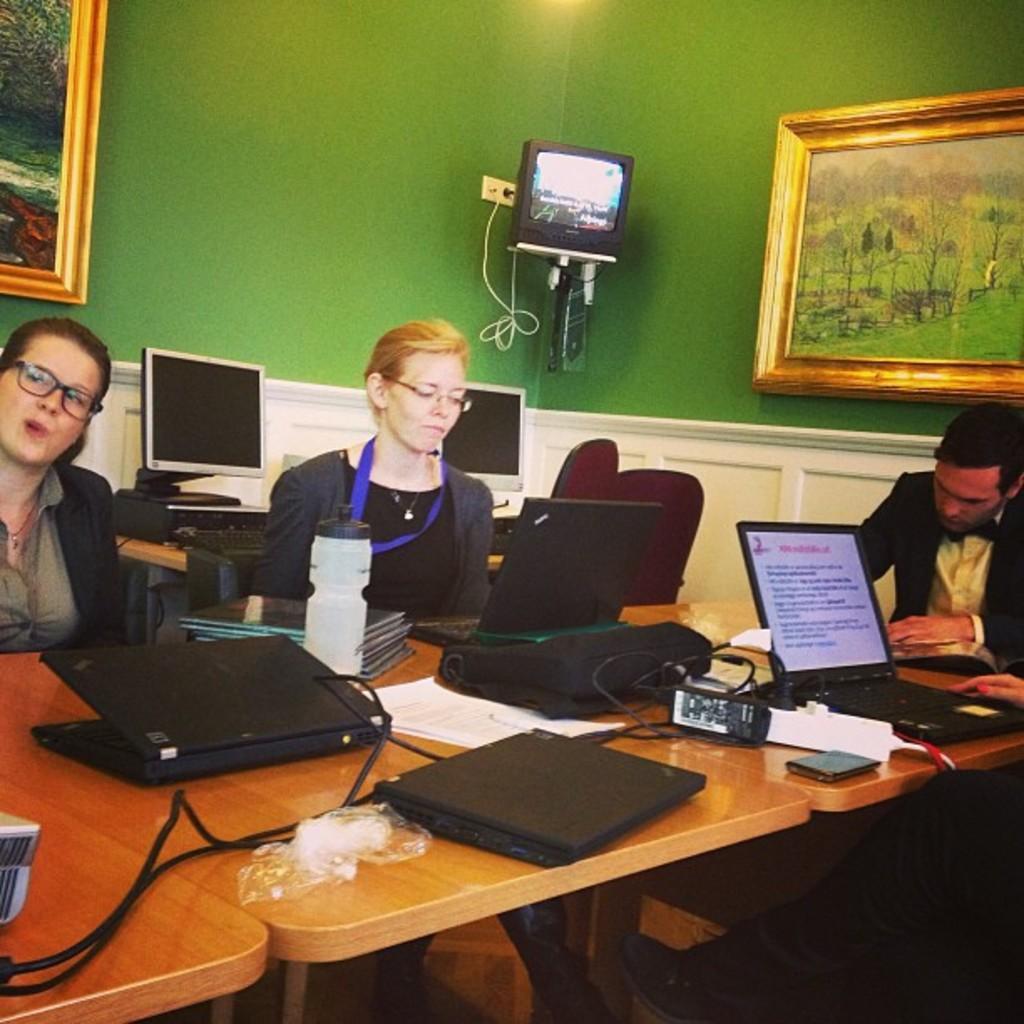Please provide a concise description of this image. In this image I can see 3 people sitting in a room. There are laptops, wires and papers on the tables. There are monitors at the back. There is a screen at the top and there are photo frames on the green walls. 